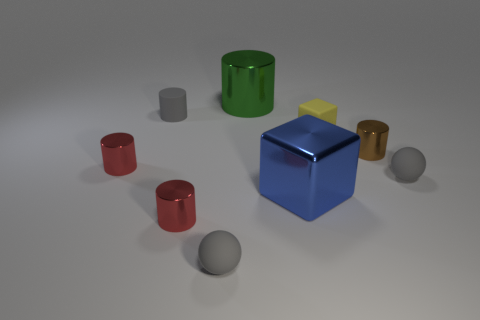The big shiny object behind the gray matte ball to the right of the small rubber ball that is on the left side of the small brown shiny thing is what color?
Give a very brief answer. Green. Is the number of small cubes right of the blue metal block less than the number of metal cylinders that are behind the tiny brown shiny cylinder?
Make the answer very short. No. Does the yellow object have the same shape as the green shiny object?
Your answer should be very brief. No. How many green metal cylinders are the same size as the yellow block?
Offer a very short reply. 0. Are there fewer rubber things that are behind the small brown thing than gray rubber cylinders?
Your answer should be compact. No. There is a gray matte object that is behind the sphere right of the green shiny cylinder; what size is it?
Provide a succinct answer. Small. What number of things are either gray objects or tiny green matte spheres?
Keep it short and to the point. 3. Are there any tiny rubber spheres that have the same color as the small cube?
Ensure brevity in your answer.  No. Is the number of big brown cubes less than the number of brown cylinders?
Your answer should be very brief. Yes. What number of things are big green metallic cylinders or cylinders behind the yellow matte object?
Offer a very short reply. 2. 